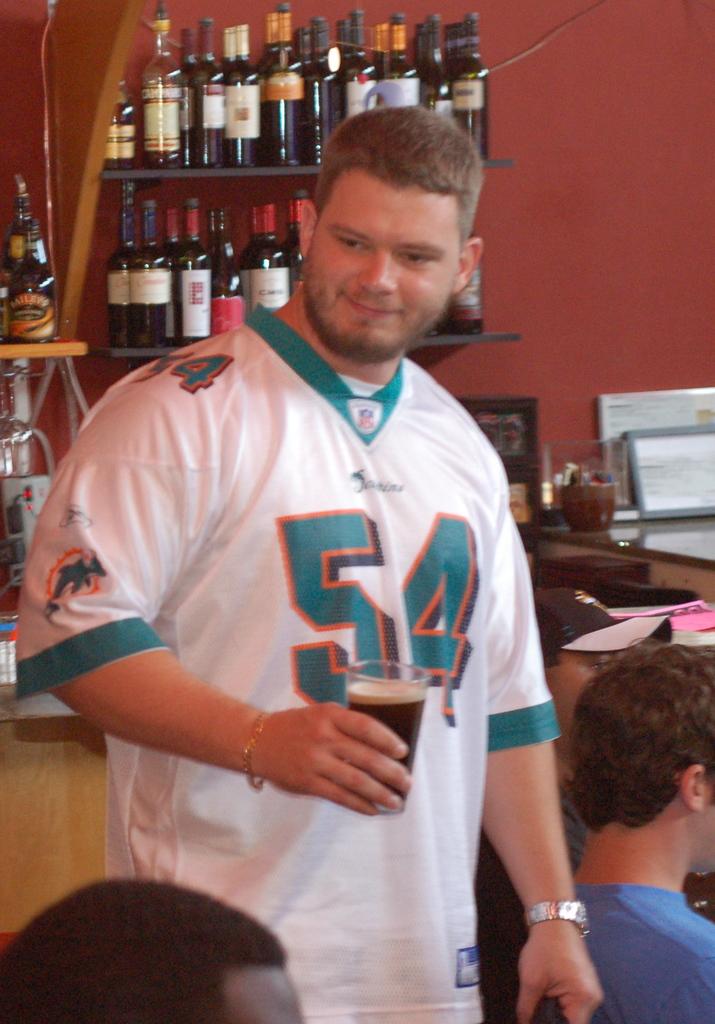What team is the jersey for?
Make the answer very short. Dolphins. 